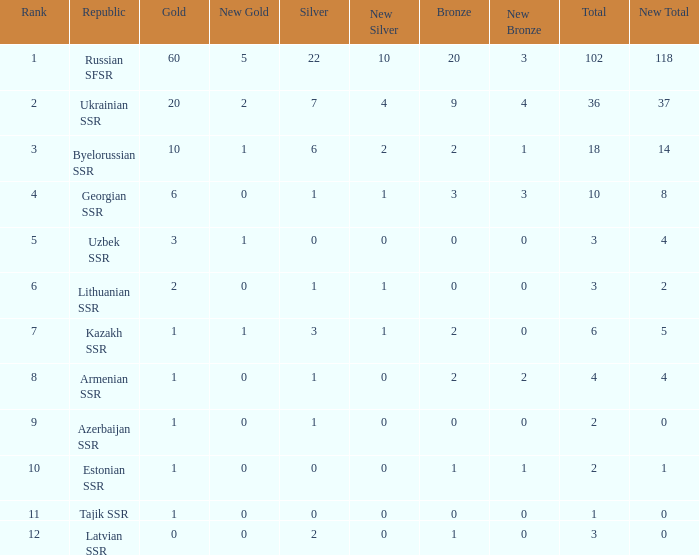What is the highest number of bronzes for teams ranked number 7 with more than 0 silver? 2.0. Would you be able to parse every entry in this table? {'header': ['Rank', 'Republic', 'Gold', 'New Gold', 'Silver', 'New Silver', 'Bronze', 'New Bronze', 'Total', 'New Total'], 'rows': [['1', 'Russian SFSR', '60', '5', '22', '10', '20', '3', '102', '118'], ['2', 'Ukrainian SSR', '20', '2', '7', '4', '9', '4', '36', '37'], ['3', 'Byelorussian SSR', '10', '1', '6', '2', '2', '1', '18', '14'], ['4', 'Georgian SSR', '6', '0', '1', '1', '3', '3', '10', '8'], ['5', 'Uzbek SSR', '3', '1', '0', '0', '0', '0', '3', '4'], ['6', 'Lithuanian SSR', '2', '0', '1', '1', '0', '0', '3', '2'], ['7', 'Kazakh SSR', '1', '1', '3', '1', '2', '0', '6', '5'], ['8', 'Armenian SSR', '1', '0', '1', '0', '2', '2', '4', '4'], ['9', 'Azerbaijan SSR', '1', '0', '1', '0', '0', '0', '2', '0'], ['10', 'Estonian SSR', '1', '0', '0', '0', '1', '1', '2', '1'], ['11', 'Tajik SSR', '1', '0', '0', '0', '0', '0', '1', '0'], ['12', 'Latvian SSR', '0', '0', '2', '0', '1', '0', '3', '0']]} 